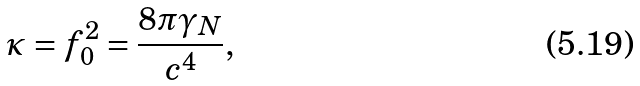<formula> <loc_0><loc_0><loc_500><loc_500>\kappa = f _ { 0 } ^ { 2 } = \frac { 8 \pi \gamma _ { N } } { c ^ { 4 } } ,</formula> 